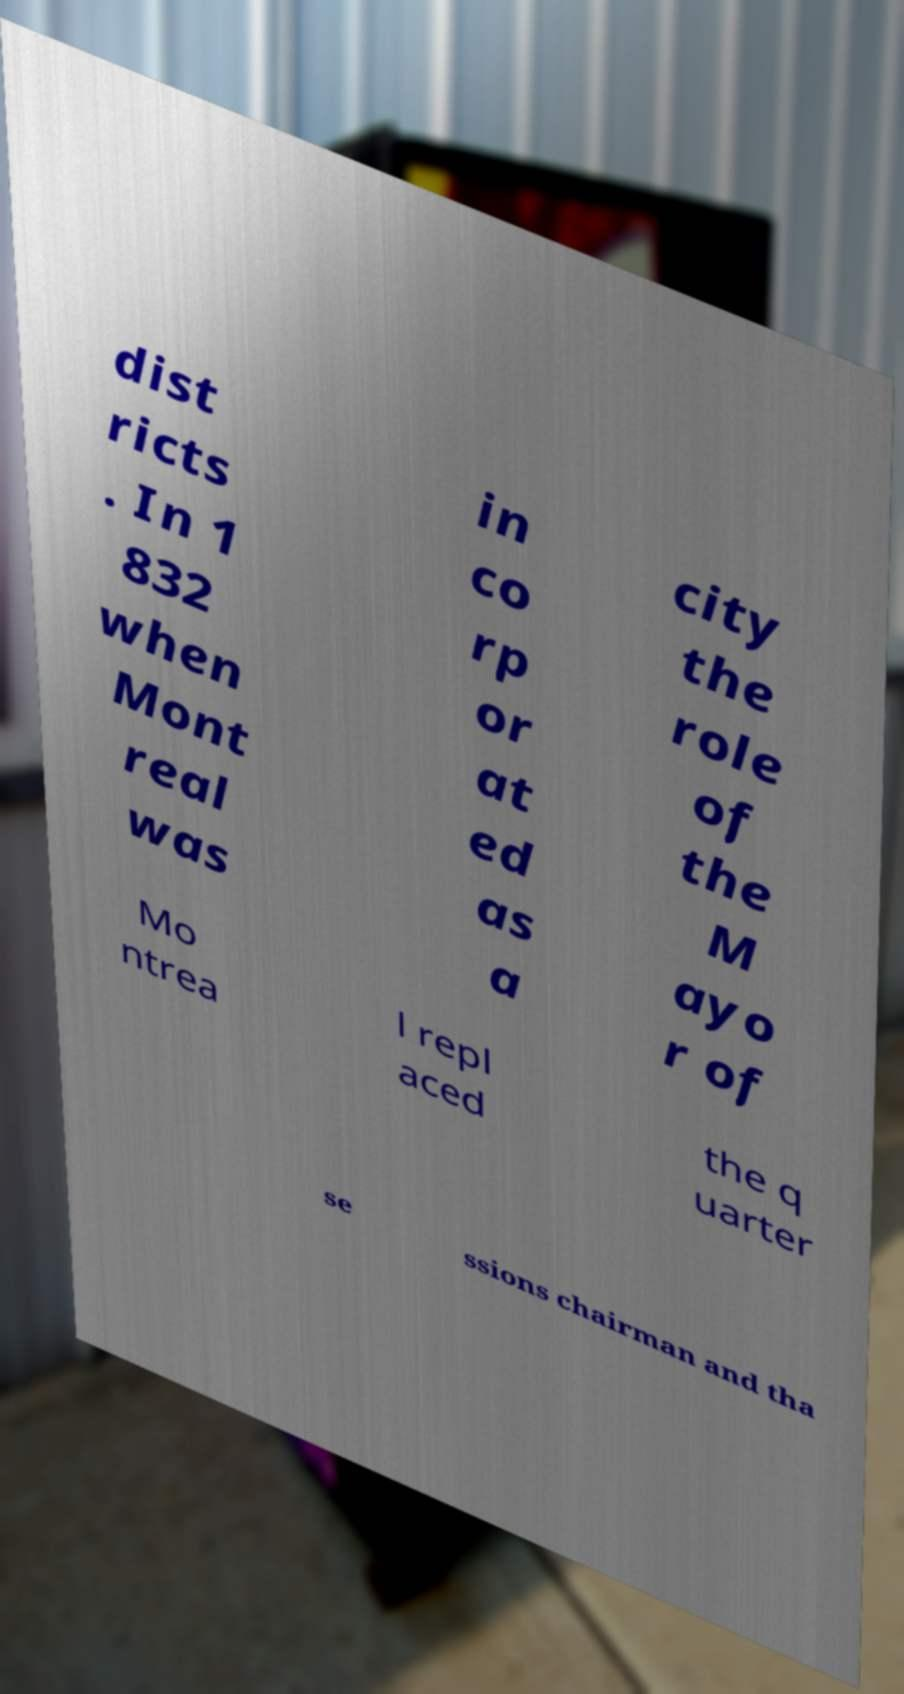For documentation purposes, I need the text within this image transcribed. Could you provide that? dist ricts . In 1 832 when Mont real was in co rp or at ed as a city the role of the M ayo r of Mo ntrea l repl aced the q uarter se ssions chairman and tha 